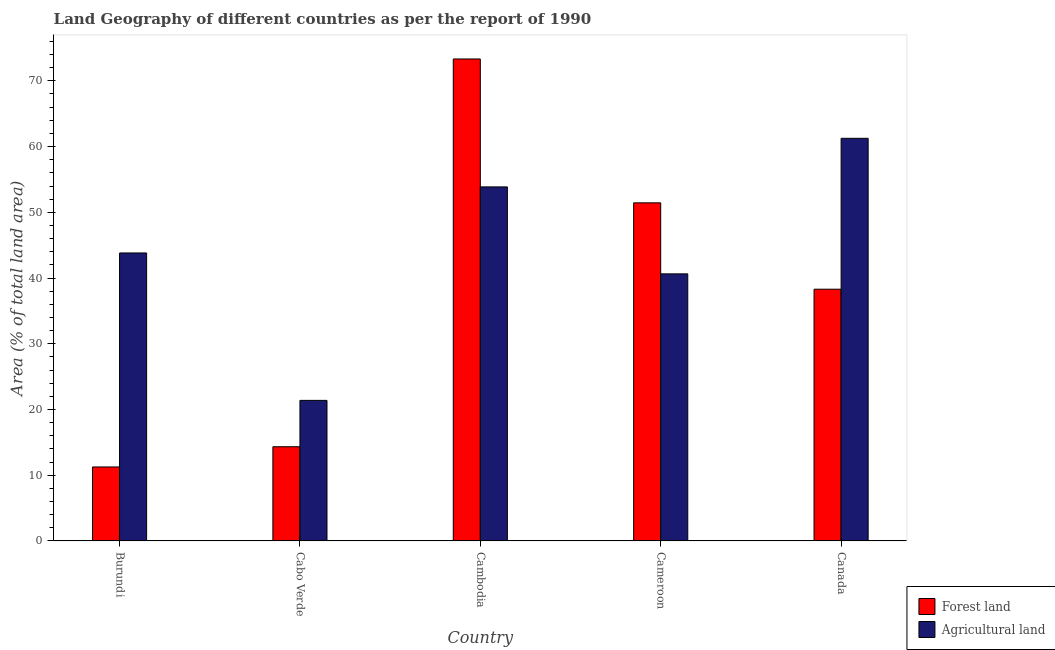How many different coloured bars are there?
Your response must be concise. 2. How many bars are there on the 1st tick from the right?
Provide a short and direct response. 2. What is the label of the 2nd group of bars from the left?
Make the answer very short. Cabo Verde. In how many cases, is the number of bars for a given country not equal to the number of legend labels?
Provide a short and direct response. 0. What is the percentage of land area under forests in Canada?
Keep it short and to the point. 38.3. Across all countries, what is the maximum percentage of land area under agriculture?
Your response must be concise. 61.26. Across all countries, what is the minimum percentage of land area under forests?
Provide a short and direct response. 11.25. In which country was the percentage of land area under agriculture maximum?
Provide a succinct answer. Canada. In which country was the percentage of land area under forests minimum?
Keep it short and to the point. Burundi. What is the total percentage of land area under agriculture in the graph?
Give a very brief answer. 220.95. What is the difference between the percentage of land area under forests in Burundi and that in Canada?
Provide a short and direct response. -27.05. What is the difference between the percentage of land area under forests in Canada and the percentage of land area under agriculture in Burundi?
Offer a very short reply. -5.52. What is the average percentage of land area under agriculture per country?
Make the answer very short. 44.19. What is the difference between the percentage of land area under forests and percentage of land area under agriculture in Cabo Verde?
Your response must be concise. -7.05. In how many countries, is the percentage of land area under agriculture greater than 24 %?
Your answer should be compact. 4. What is the ratio of the percentage of land area under forests in Cameroon to that in Canada?
Your answer should be compact. 1.34. Is the difference between the percentage of land area under forests in Burundi and Cameroon greater than the difference between the percentage of land area under agriculture in Burundi and Cameroon?
Your response must be concise. No. What is the difference between the highest and the second highest percentage of land area under agriculture?
Give a very brief answer. 7.39. What is the difference between the highest and the lowest percentage of land area under agriculture?
Offer a very short reply. 39.87. What does the 1st bar from the left in Cameroon represents?
Your answer should be very brief. Forest land. What does the 2nd bar from the right in Burundi represents?
Offer a very short reply. Forest land. How many bars are there?
Ensure brevity in your answer.  10. Are all the bars in the graph horizontal?
Offer a terse response. No. How many countries are there in the graph?
Provide a succinct answer. 5. What is the difference between two consecutive major ticks on the Y-axis?
Your response must be concise. 10. Does the graph contain any zero values?
Provide a short and direct response. No. Where does the legend appear in the graph?
Make the answer very short. Bottom right. How are the legend labels stacked?
Provide a succinct answer. Vertical. What is the title of the graph?
Keep it short and to the point. Land Geography of different countries as per the report of 1990. Does "Not attending school" appear as one of the legend labels in the graph?
Your response must be concise. No. What is the label or title of the X-axis?
Give a very brief answer. Country. What is the label or title of the Y-axis?
Your answer should be very brief. Area (% of total land area). What is the Area (% of total land area) in Forest land in Burundi?
Give a very brief answer. 11.25. What is the Area (% of total land area) in Agricultural land in Burundi?
Offer a terse response. 43.81. What is the Area (% of total land area) in Forest land in Cabo Verde?
Keep it short and to the point. 14.33. What is the Area (% of total land area) of Agricultural land in Cabo Verde?
Your answer should be very brief. 21.38. What is the Area (% of total land area) of Forest land in Cambodia?
Give a very brief answer. 73.33. What is the Area (% of total land area) in Agricultural land in Cambodia?
Provide a succinct answer. 53.86. What is the Area (% of total land area) of Forest land in Cameroon?
Offer a very short reply. 51.44. What is the Area (% of total land area) in Agricultural land in Cameroon?
Offer a very short reply. 40.63. What is the Area (% of total land area) of Forest land in Canada?
Keep it short and to the point. 38.3. What is the Area (% of total land area) of Agricultural land in Canada?
Keep it short and to the point. 61.26. Across all countries, what is the maximum Area (% of total land area) of Forest land?
Offer a terse response. 73.33. Across all countries, what is the maximum Area (% of total land area) of Agricultural land?
Make the answer very short. 61.26. Across all countries, what is the minimum Area (% of total land area) of Forest land?
Your answer should be very brief. 11.25. Across all countries, what is the minimum Area (% of total land area) of Agricultural land?
Offer a terse response. 21.38. What is the total Area (% of total land area) of Forest land in the graph?
Make the answer very short. 188.65. What is the total Area (% of total land area) of Agricultural land in the graph?
Give a very brief answer. 220.95. What is the difference between the Area (% of total land area) in Forest land in Burundi and that in Cabo Verde?
Offer a very short reply. -3.08. What is the difference between the Area (% of total land area) of Agricultural land in Burundi and that in Cabo Verde?
Provide a succinct answer. 22.43. What is the difference between the Area (% of total land area) of Forest land in Burundi and that in Cambodia?
Your response must be concise. -62.07. What is the difference between the Area (% of total land area) of Agricultural land in Burundi and that in Cambodia?
Keep it short and to the point. -10.05. What is the difference between the Area (% of total land area) of Forest land in Burundi and that in Cameroon?
Provide a succinct answer. -40.19. What is the difference between the Area (% of total land area) in Agricultural land in Burundi and that in Cameroon?
Your answer should be very brief. 3.18. What is the difference between the Area (% of total land area) of Forest land in Burundi and that in Canada?
Your response must be concise. -27.05. What is the difference between the Area (% of total land area) in Agricultural land in Burundi and that in Canada?
Your response must be concise. -17.44. What is the difference between the Area (% of total land area) of Forest land in Cabo Verde and that in Cambodia?
Ensure brevity in your answer.  -59. What is the difference between the Area (% of total land area) of Agricultural land in Cabo Verde and that in Cambodia?
Offer a terse response. -32.48. What is the difference between the Area (% of total land area) of Forest land in Cabo Verde and that in Cameroon?
Offer a terse response. -37.11. What is the difference between the Area (% of total land area) of Agricultural land in Cabo Verde and that in Cameroon?
Provide a short and direct response. -19.25. What is the difference between the Area (% of total land area) of Forest land in Cabo Verde and that in Canada?
Your answer should be compact. -23.97. What is the difference between the Area (% of total land area) in Agricultural land in Cabo Verde and that in Canada?
Provide a succinct answer. -39.87. What is the difference between the Area (% of total land area) of Forest land in Cambodia and that in Cameroon?
Make the answer very short. 21.89. What is the difference between the Area (% of total land area) of Agricultural land in Cambodia and that in Cameroon?
Ensure brevity in your answer.  13.23. What is the difference between the Area (% of total land area) of Forest land in Cambodia and that in Canada?
Offer a very short reply. 35.03. What is the difference between the Area (% of total land area) of Agricultural land in Cambodia and that in Canada?
Make the answer very short. -7.39. What is the difference between the Area (% of total land area) of Forest land in Cameroon and that in Canada?
Keep it short and to the point. 13.14. What is the difference between the Area (% of total land area) of Agricultural land in Cameroon and that in Canada?
Keep it short and to the point. -20.62. What is the difference between the Area (% of total land area) in Forest land in Burundi and the Area (% of total land area) in Agricultural land in Cabo Verde?
Your answer should be compact. -10.13. What is the difference between the Area (% of total land area) in Forest land in Burundi and the Area (% of total land area) in Agricultural land in Cambodia?
Offer a very short reply. -42.61. What is the difference between the Area (% of total land area) in Forest land in Burundi and the Area (% of total land area) in Agricultural land in Cameroon?
Offer a very short reply. -29.38. What is the difference between the Area (% of total land area) in Forest land in Burundi and the Area (% of total land area) in Agricultural land in Canada?
Your response must be concise. -50. What is the difference between the Area (% of total land area) in Forest land in Cabo Verde and the Area (% of total land area) in Agricultural land in Cambodia?
Offer a very short reply. -39.53. What is the difference between the Area (% of total land area) of Forest land in Cabo Verde and the Area (% of total land area) of Agricultural land in Cameroon?
Offer a very short reply. -26.3. What is the difference between the Area (% of total land area) of Forest land in Cabo Verde and the Area (% of total land area) of Agricultural land in Canada?
Offer a very short reply. -46.93. What is the difference between the Area (% of total land area) in Forest land in Cambodia and the Area (% of total land area) in Agricultural land in Cameroon?
Offer a terse response. 32.7. What is the difference between the Area (% of total land area) in Forest land in Cambodia and the Area (% of total land area) in Agricultural land in Canada?
Keep it short and to the point. 12.07. What is the difference between the Area (% of total land area) in Forest land in Cameroon and the Area (% of total land area) in Agricultural land in Canada?
Provide a succinct answer. -9.82. What is the average Area (% of total land area) of Forest land per country?
Your answer should be compact. 37.73. What is the average Area (% of total land area) of Agricultural land per country?
Your response must be concise. 44.19. What is the difference between the Area (% of total land area) in Forest land and Area (% of total land area) in Agricultural land in Burundi?
Offer a terse response. -32.56. What is the difference between the Area (% of total land area) in Forest land and Area (% of total land area) in Agricultural land in Cabo Verde?
Your answer should be very brief. -7.05. What is the difference between the Area (% of total land area) of Forest land and Area (% of total land area) of Agricultural land in Cambodia?
Your response must be concise. 19.46. What is the difference between the Area (% of total land area) of Forest land and Area (% of total land area) of Agricultural land in Cameroon?
Give a very brief answer. 10.81. What is the difference between the Area (% of total land area) in Forest land and Area (% of total land area) in Agricultural land in Canada?
Your response must be concise. -22.96. What is the ratio of the Area (% of total land area) in Forest land in Burundi to that in Cabo Verde?
Offer a very short reply. 0.79. What is the ratio of the Area (% of total land area) of Agricultural land in Burundi to that in Cabo Verde?
Make the answer very short. 2.05. What is the ratio of the Area (% of total land area) in Forest land in Burundi to that in Cambodia?
Offer a very short reply. 0.15. What is the ratio of the Area (% of total land area) in Agricultural land in Burundi to that in Cambodia?
Provide a succinct answer. 0.81. What is the ratio of the Area (% of total land area) of Forest land in Burundi to that in Cameroon?
Provide a succinct answer. 0.22. What is the ratio of the Area (% of total land area) of Agricultural land in Burundi to that in Cameroon?
Your answer should be compact. 1.08. What is the ratio of the Area (% of total land area) of Forest land in Burundi to that in Canada?
Keep it short and to the point. 0.29. What is the ratio of the Area (% of total land area) in Agricultural land in Burundi to that in Canada?
Give a very brief answer. 0.72. What is the ratio of the Area (% of total land area) in Forest land in Cabo Verde to that in Cambodia?
Keep it short and to the point. 0.2. What is the ratio of the Area (% of total land area) of Agricultural land in Cabo Verde to that in Cambodia?
Your response must be concise. 0.4. What is the ratio of the Area (% of total land area) of Forest land in Cabo Verde to that in Cameroon?
Make the answer very short. 0.28. What is the ratio of the Area (% of total land area) of Agricultural land in Cabo Verde to that in Cameroon?
Your response must be concise. 0.53. What is the ratio of the Area (% of total land area) of Forest land in Cabo Verde to that in Canada?
Make the answer very short. 0.37. What is the ratio of the Area (% of total land area) in Agricultural land in Cabo Verde to that in Canada?
Offer a very short reply. 0.35. What is the ratio of the Area (% of total land area) in Forest land in Cambodia to that in Cameroon?
Offer a terse response. 1.43. What is the ratio of the Area (% of total land area) in Agricultural land in Cambodia to that in Cameroon?
Ensure brevity in your answer.  1.33. What is the ratio of the Area (% of total land area) in Forest land in Cambodia to that in Canada?
Make the answer very short. 1.91. What is the ratio of the Area (% of total land area) in Agricultural land in Cambodia to that in Canada?
Provide a succinct answer. 0.88. What is the ratio of the Area (% of total land area) in Forest land in Cameroon to that in Canada?
Provide a succinct answer. 1.34. What is the ratio of the Area (% of total land area) of Agricultural land in Cameroon to that in Canada?
Your response must be concise. 0.66. What is the difference between the highest and the second highest Area (% of total land area) in Forest land?
Offer a terse response. 21.89. What is the difference between the highest and the second highest Area (% of total land area) in Agricultural land?
Provide a succinct answer. 7.39. What is the difference between the highest and the lowest Area (% of total land area) of Forest land?
Provide a short and direct response. 62.07. What is the difference between the highest and the lowest Area (% of total land area) in Agricultural land?
Ensure brevity in your answer.  39.87. 